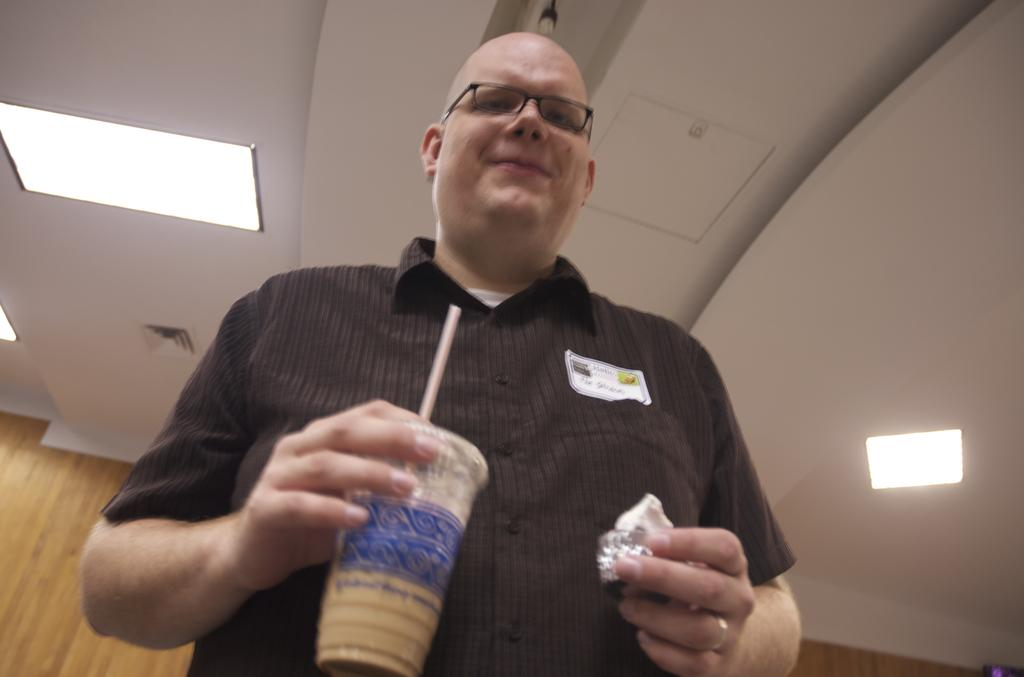What is the main subject of the image? There is a man in the image. What is the man holding in the image? The man is holding a glass with his hand. What type of lighting is present in the image? There are ceiling lights visible in the image. What type of poison is the man using in the image? There is no poison present in the image; the man is simply holding a glass. What type of frame surrounds the image? The provided facts do not mention a frame surrounding the image. 